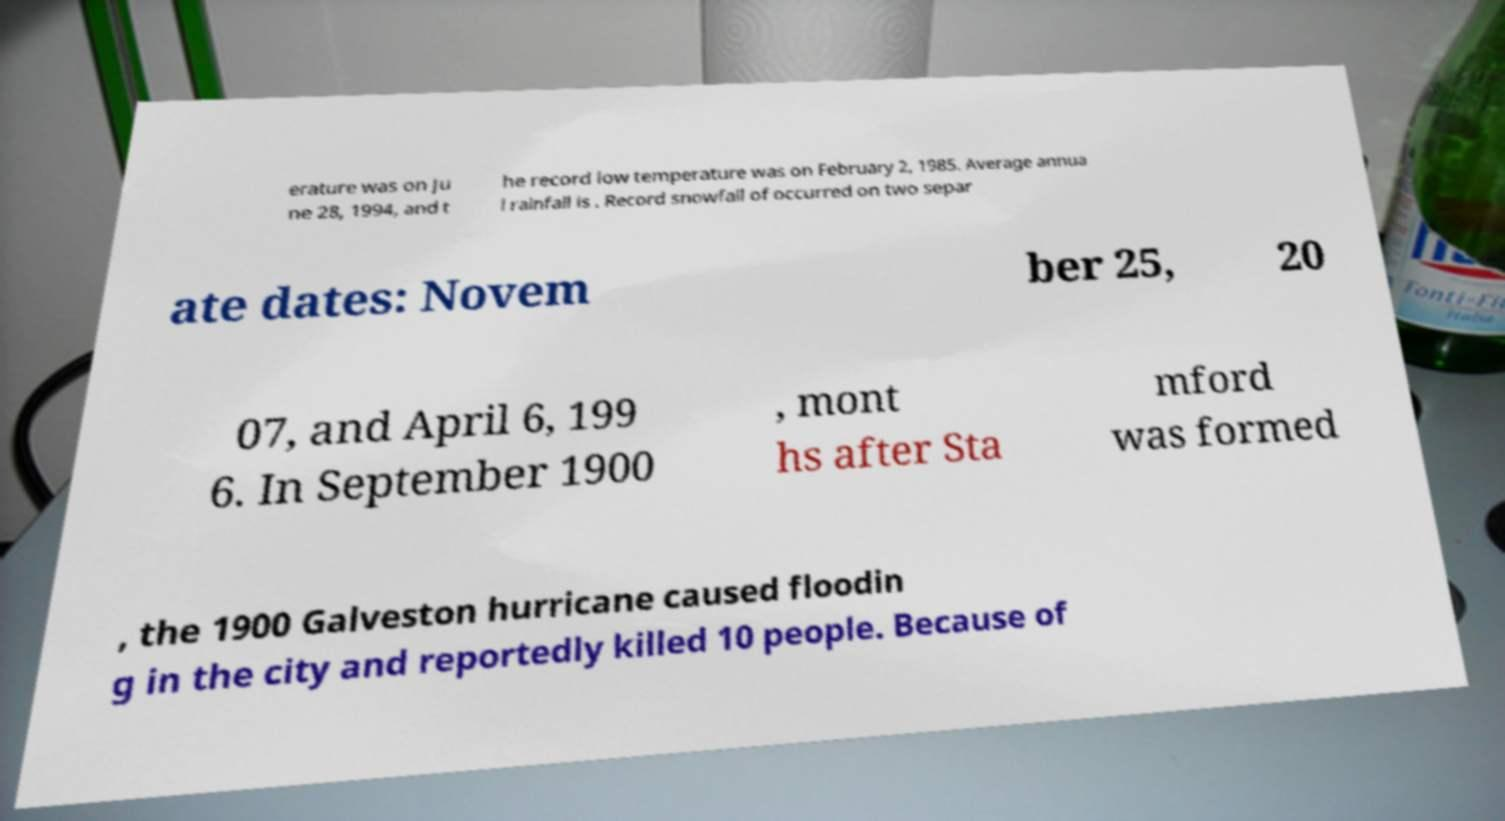Could you extract and type out the text from this image? erature was on Ju ne 28, 1994, and t he record low temperature was on February 2, 1985. Average annua l rainfall is . Record snowfall of occurred on two separ ate dates: Novem ber 25, 20 07, and April 6, 199 6. In September 1900 , mont hs after Sta mford was formed , the 1900 Galveston hurricane caused floodin g in the city and reportedly killed 10 people. Because of 